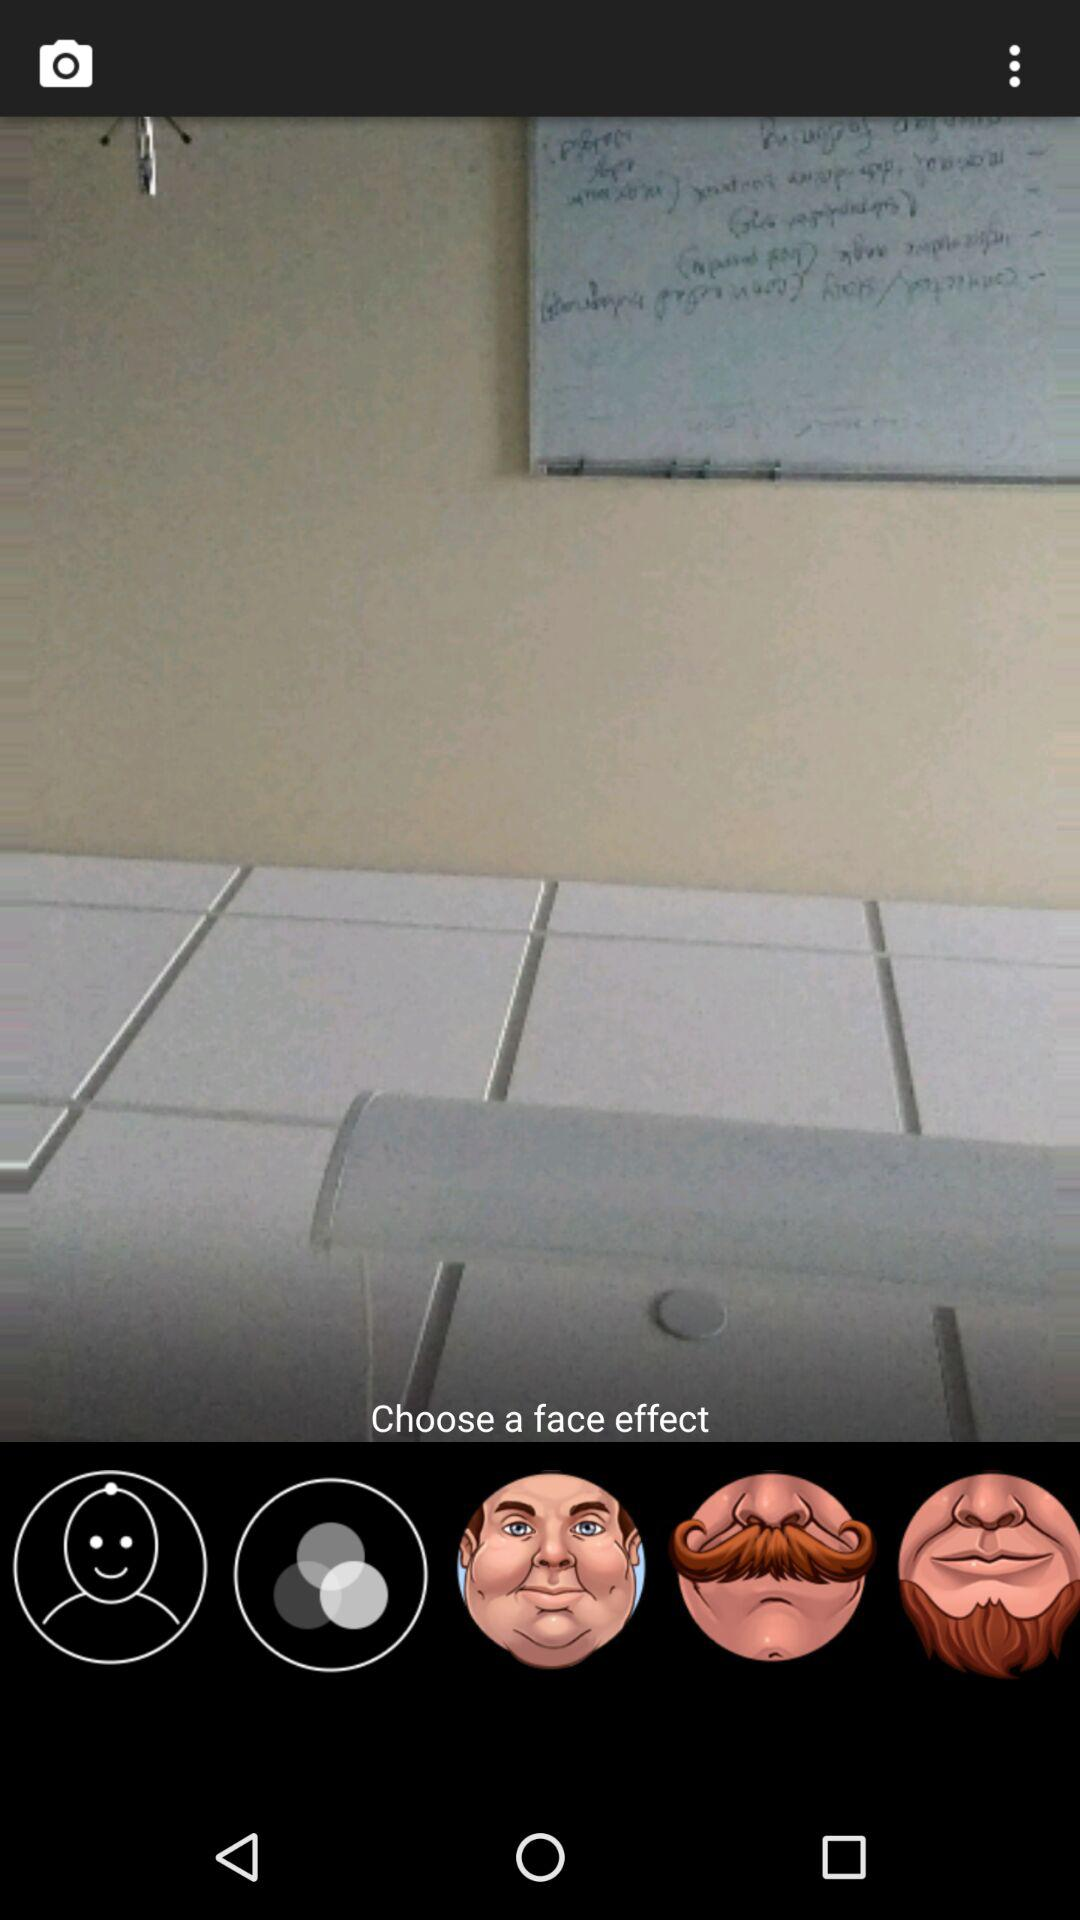How many face effects are there in total?
Answer the question using a single word or phrase. 3 